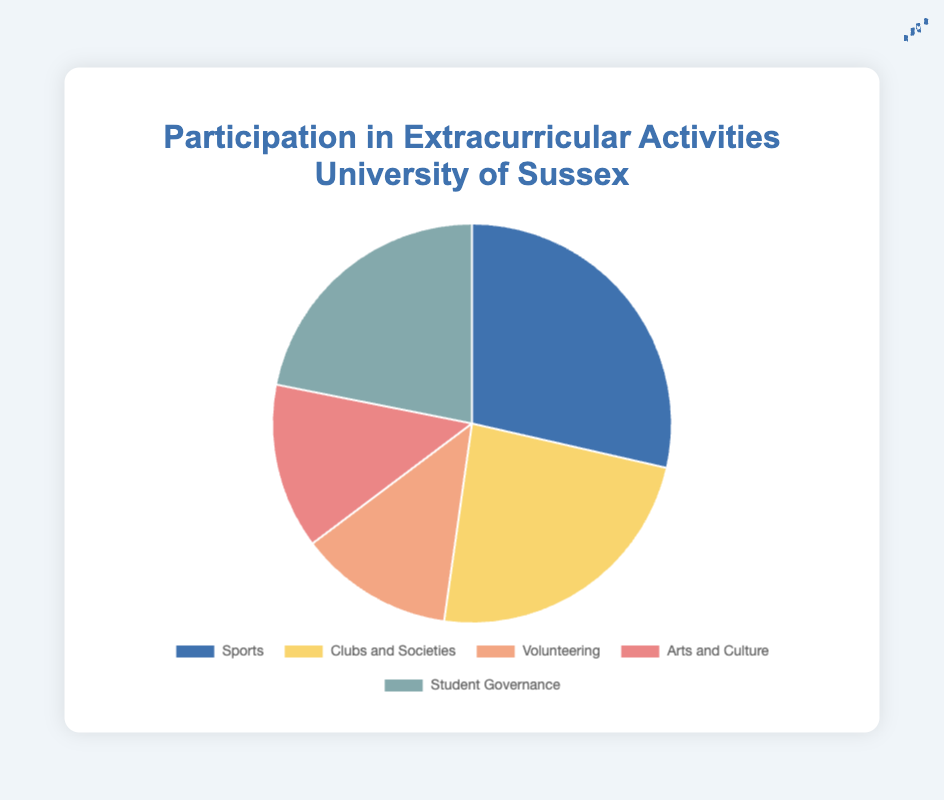what's the total participation in volunteering and student governance combined? The participation in volunteering is 140, and in student governance is 245. Summing these up gives 140 + 245 = 385
Answer: 385 which category has the highest participation? By looking at the chart, the category with the largest slice represents Sports, with the highest value of 320 participants
Answer: Sports how many more participants are there in sports compared to clubs and societies? Participation in sports is 320, and in clubs and societies is 265. The difference is 320 - 265 = 55
Answer: 55 what is the percentage of students participating in arts and culture activities? The total number of participants is the sum of all categories, which is 320 + 265 + 140 + 150 + 245 = 1120. So, the percentage for arts and culture is (150 / 1120) * 100% = 13.39%
Answer: 13.39% are there more participants in categories with high visual impact (blue and yellow) combined compared to other categories? Blue (sports) has 320 and yellow (clubs and societies) has 265, their combined total is 320 + 265 = 585. Other categories have 140 + 150 + 245 = 535. Since 585 > 535, there are more participants in blue and yellow categories combined
Answer: Yes rank the categories from highest to lowest participation The categories by decreasing participation are sports (320), clubs and societies (265), student governance (245), arts and culture (150), and volunteering (140)
Answer: Sports > Clubs and Societies > Student Governance > Arts and Culture > Volunteering what portion of the chart represents clubs and societies? The number of participants in clubs and societies is 265. The total number of participants is 320 + 265 + 140 + 150 + 245 = 1120. So, the portion is 265 / 1120 ≈ 23.66%
Answer: 23.66% compare the participation in arts and culture to volunteering – which category is larger and by how much? Arts and culture has 150 participants, and volunteering has 140 participants. The difference is 150 - 140 = 10, so arts and culture is larger by 10 participants
Answer: Arts and Culture by 10 which category has the second lowest participation, and how many participants are there in that category? The second-lowest category in the chart is arts and culture, with 150 participants
Answer: Arts and Culture, 150 participants 